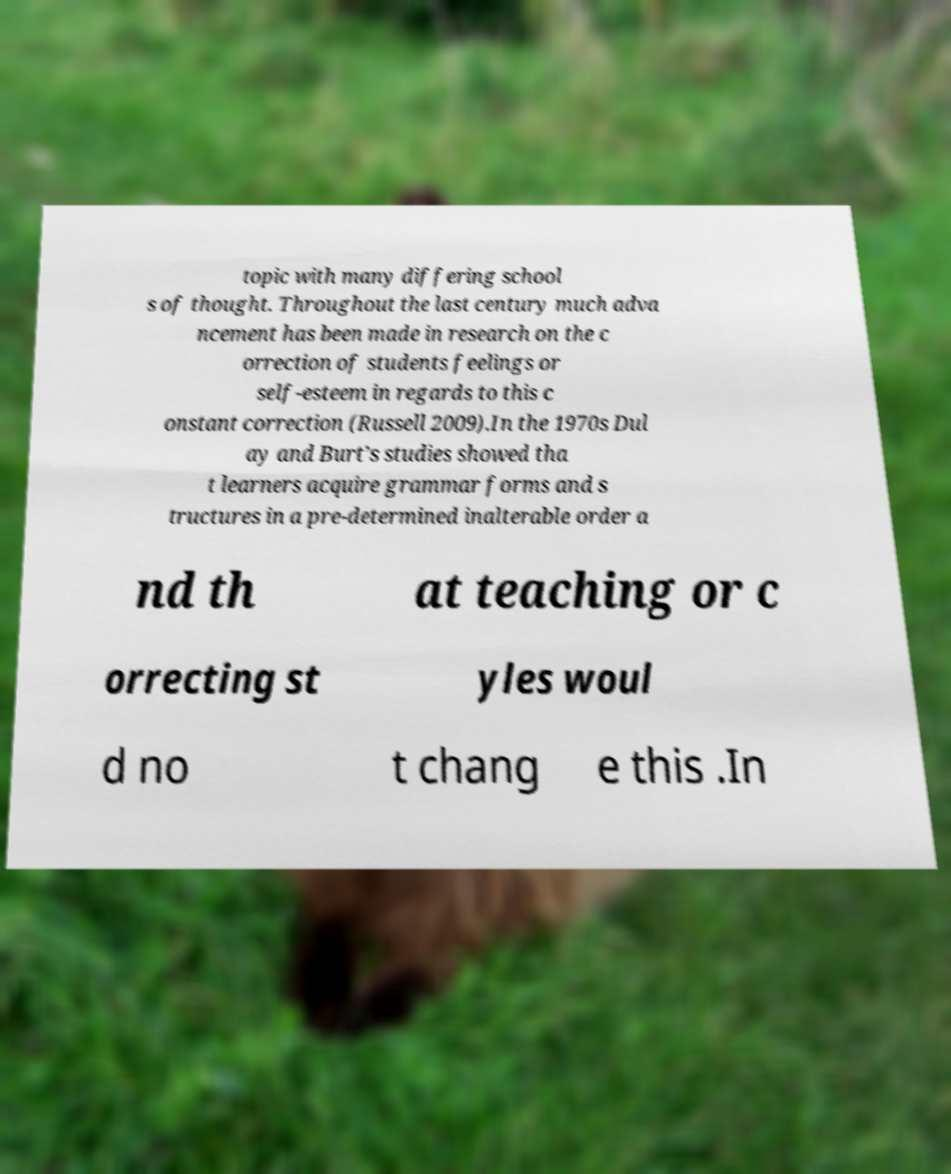I need the written content from this picture converted into text. Can you do that? topic with many differing school s of thought. Throughout the last century much adva ncement has been made in research on the c orrection of students feelings or self-esteem in regards to this c onstant correction (Russell 2009).In the 1970s Dul ay and Burt’s studies showed tha t learners acquire grammar forms and s tructures in a pre-determined inalterable order a nd th at teaching or c orrecting st yles woul d no t chang e this .In 